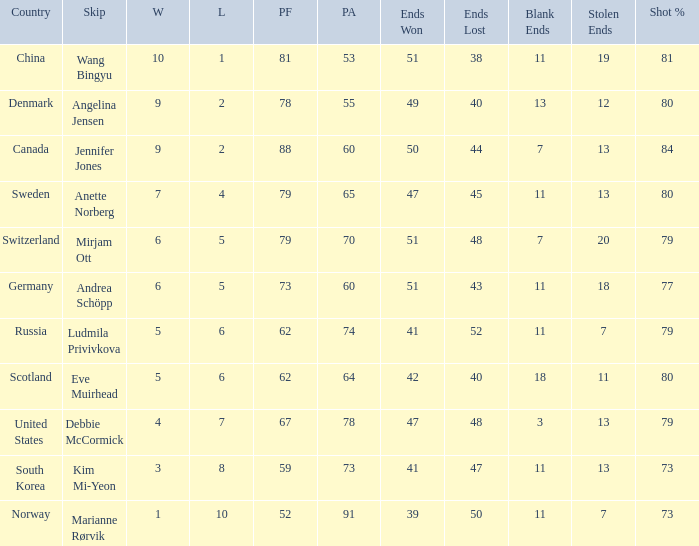What is the minimum number of wins a team possesses? 1.0. 